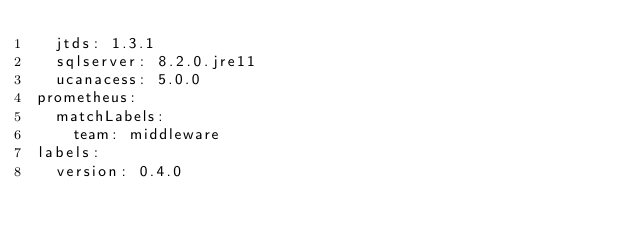<code> <loc_0><loc_0><loc_500><loc_500><_YAML_>  jtds: 1.3.1
  sqlserver: 8.2.0.jre11
  ucanacess: 5.0.0
prometheus:
  matchLabels:
    team: middleware
labels:
  version: 0.4.0
</code> 